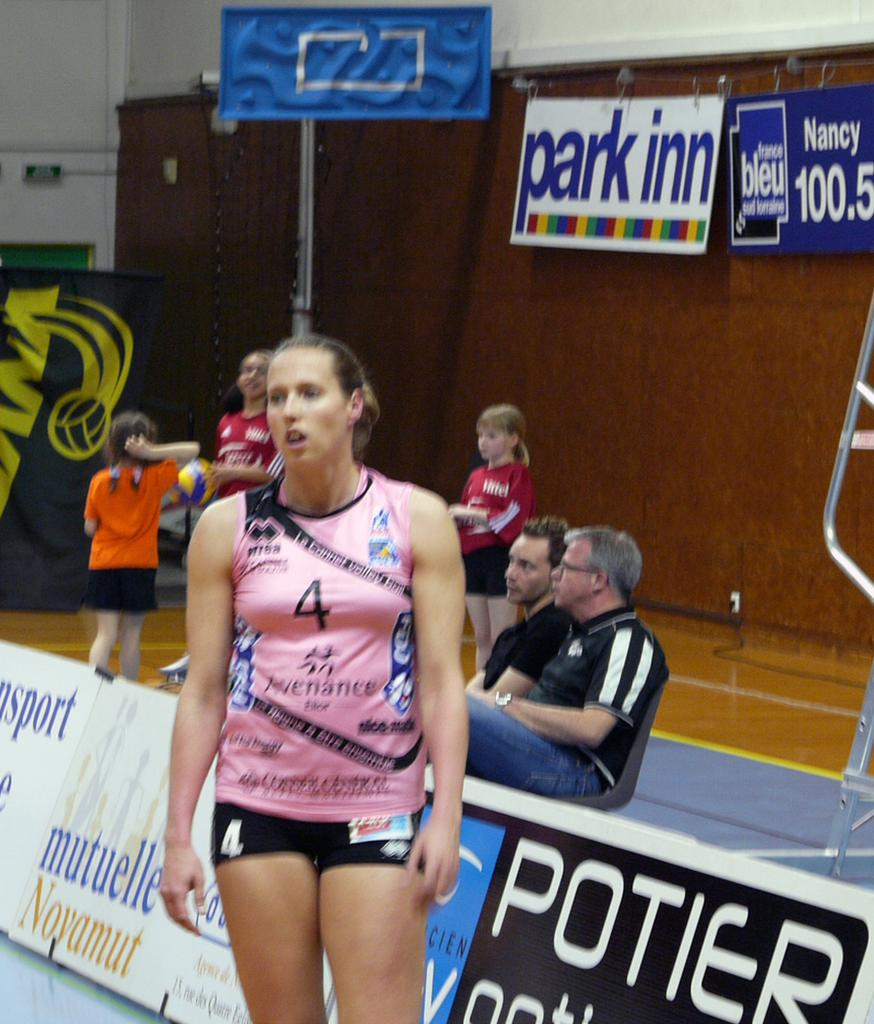<image>
Write a terse but informative summary of the picture. a girl that the number 4 on her sporting outfit 